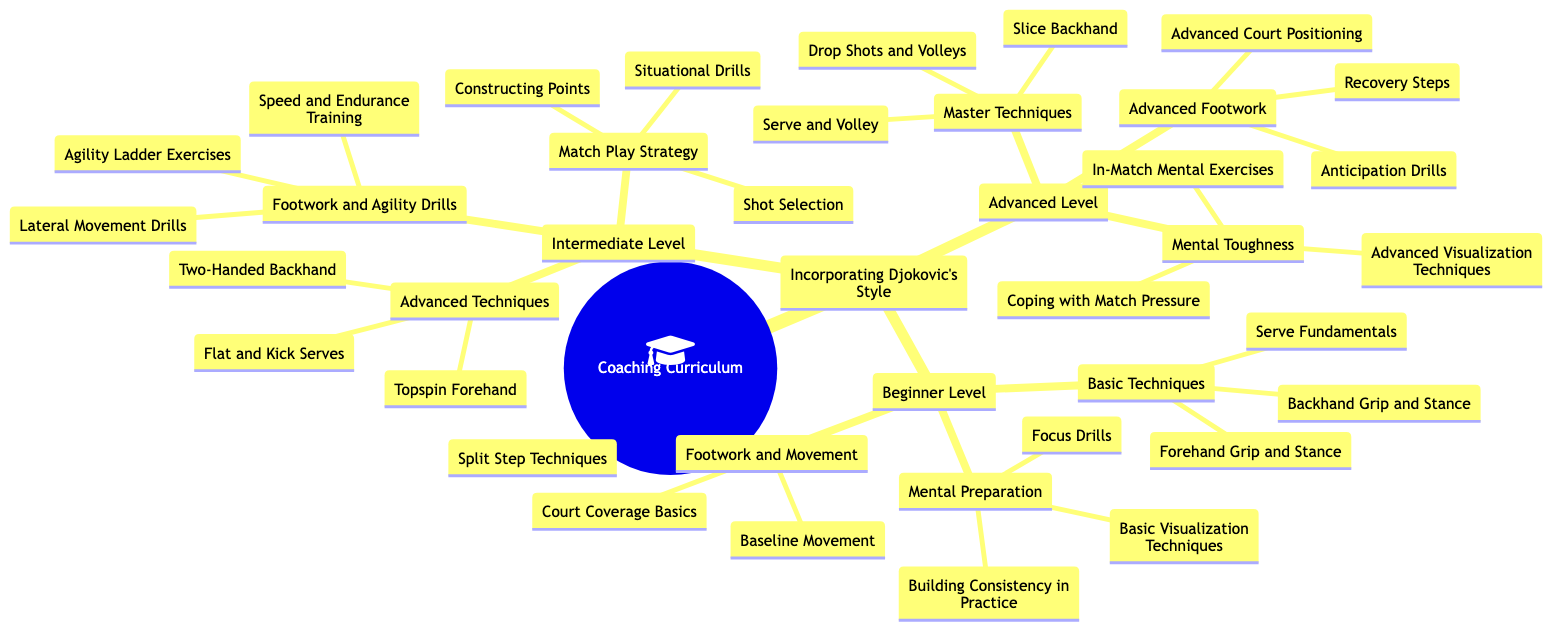What are the three categories under Beginner Level? The Beginner Level includes Basic Techniques, Footwork and Movement, and Mental Preparation. These are listed as sub-nodes under the Beginner Level node.
Answer: Basic Techniques, Footwork and Movement, Mental Preparation How many techniques are listed under Advanced Techniques in the Intermediate Level? Under Advanced Techniques, there are three specific techniques mentioned: Topspin Forehand, Two-Handed Backhand, and Flat and Kick Serves. Therefore, the count is three.
Answer: 3 What is the category focused on Mental Toughness in the Advanced Level? The category in the Advanced Level that focuses on Mental Toughness includes In-Match Mental Exercises, Advanced Visualization Techniques, and Coping with Match Pressure. These are all sub-items under Mental Toughness.
Answer: In-Match Mental Exercises, Advanced Visualization Techniques, Coping with Match Pressure How many drills are under the Footwork and Agility Drills in the Intermediate Level? The Footwork and Agility Drills includes three types of drills: Lateral Movement Drills, Agility Ladder Exercises, and Speed and Endurance Training. Thus, the total number is three.
Answer: 3 What is the relationship between Basic Techniques and Footwork and Movement in the Beginner Level? Both categories belong to the Beginner Level and represent two different areas of focus within the level. They are parallel sub-nodes, indicating they are of equal importance in the curriculum for beginners.
Answer: Parallel sub-nodes List two elements included in Master Techniques. The Master Techniques category includes Drop Shots and Volleys, and Slice Backhand. These are two specific techniques listed under Master Techniques in the Advanced Level.
Answer: Drop Shots and Volleys, Slice Backhand 